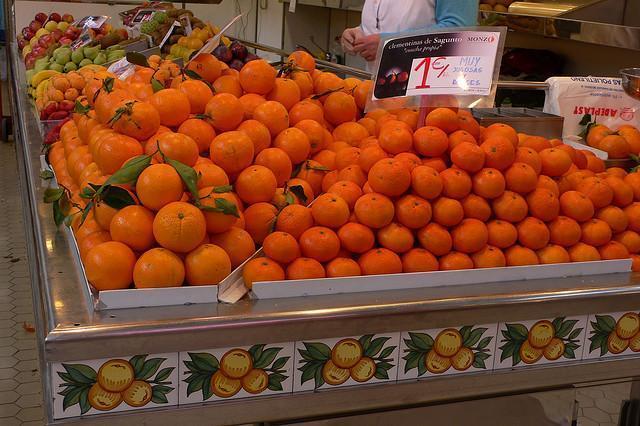How many oranges are cut?
Give a very brief answer. 0. How many oranges are there?
Give a very brief answer. 2. How many sinks can be seen?
Give a very brief answer. 0. 